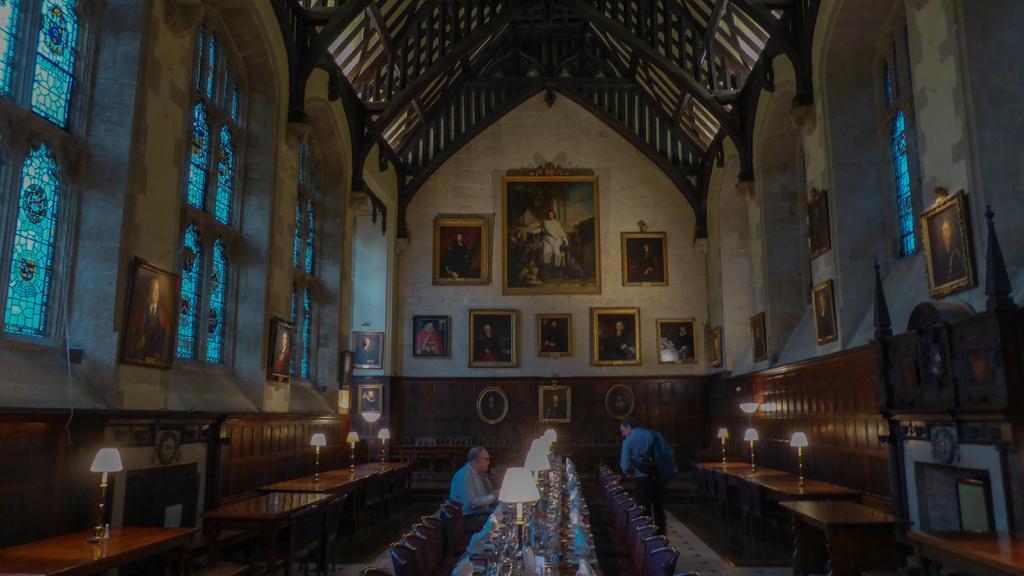Can you describe this image briefly? In this image I can see two people. One person is sitting in-front of the table and one person is standing. On the table I can see the lamps and many objects. To the side I can see the chairs. On the tables I can see the few more lamps. There are many frames and windows to the wall. And this is the inner part of the building. 